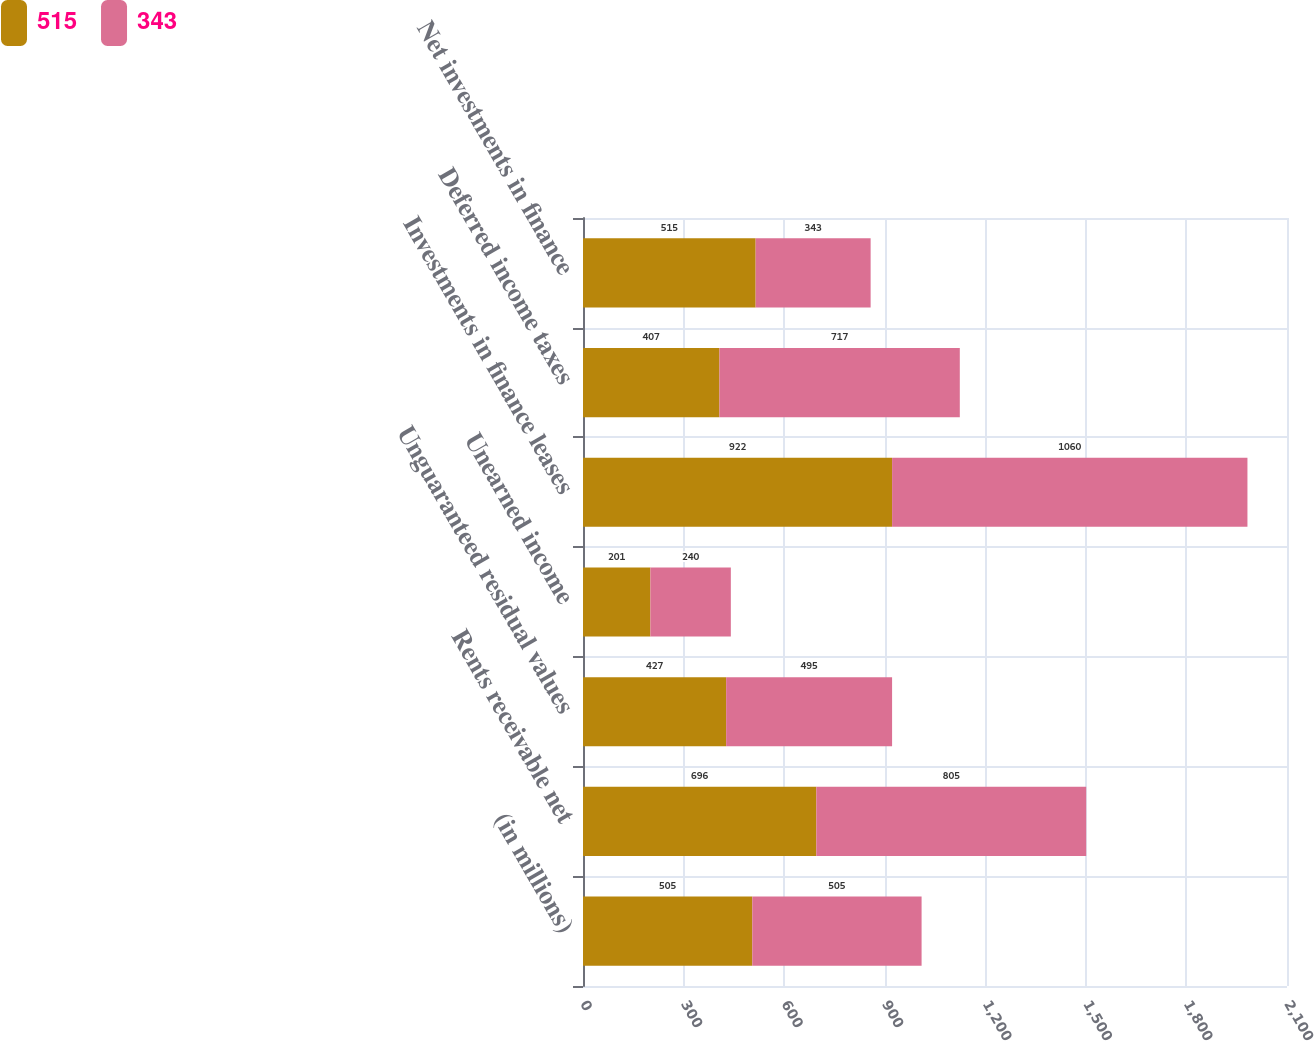Convert chart to OTSL. <chart><loc_0><loc_0><loc_500><loc_500><stacked_bar_chart><ecel><fcel>(in millions)<fcel>Rents receivable net<fcel>Unguaranteed residual values<fcel>Unearned income<fcel>Investments in finance leases<fcel>Deferred income taxes<fcel>Net investments in finance<nl><fcel>515<fcel>505<fcel>696<fcel>427<fcel>201<fcel>922<fcel>407<fcel>515<nl><fcel>343<fcel>505<fcel>805<fcel>495<fcel>240<fcel>1060<fcel>717<fcel>343<nl></chart> 